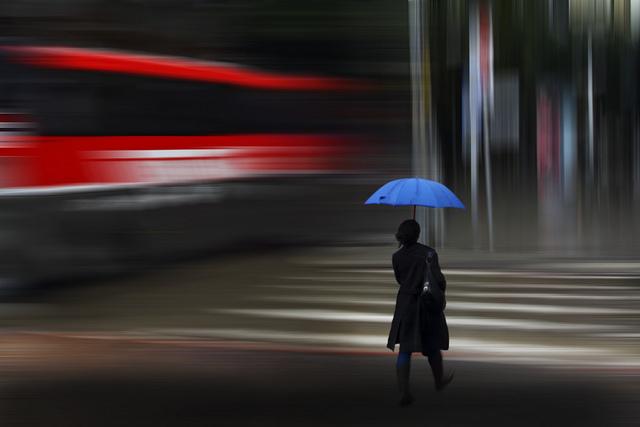What is the person wearing?
Be succinct. Coat. Have any camera effects been applied to this photo?
Short answer required. Yes. Do the horizontal stripes dominate this space?
Keep it brief. Yes. 